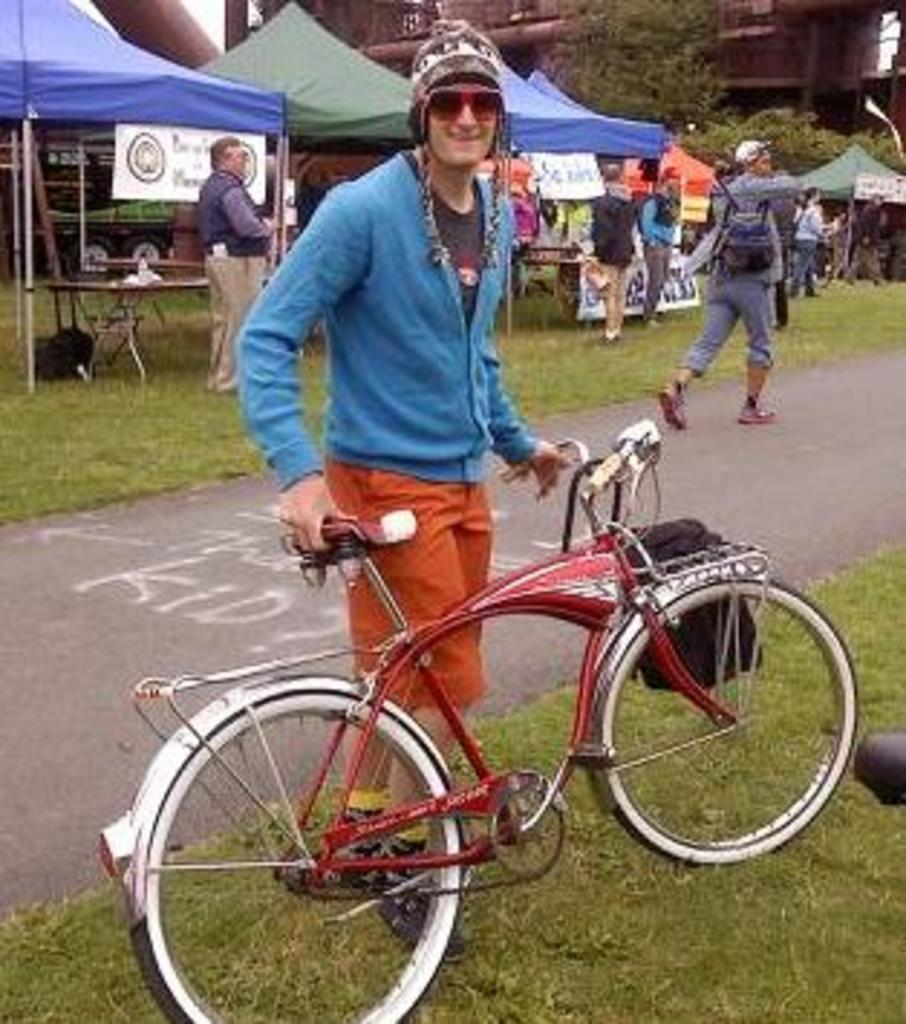What is the main subject of the image? There is a man standing in the center of the image. What is the man holding in the image? The man is holding a bicycle. What can be seen in the background of the image? There are people, tents, trees, and buildings in the background of the image. What objects are visible in the image besides the man and bicycle? There are tables visible in the image. What type of path is visible in the image? There is a road in the image. What type of haircut does the kitten have in the image? There is no kitten present in the image, so it is not possible to determine the type of haircut it might have. What is the kitten using to lock the bicycle in the image? There is no kitten or lock present in the image, so it is not possible to answer this question. 